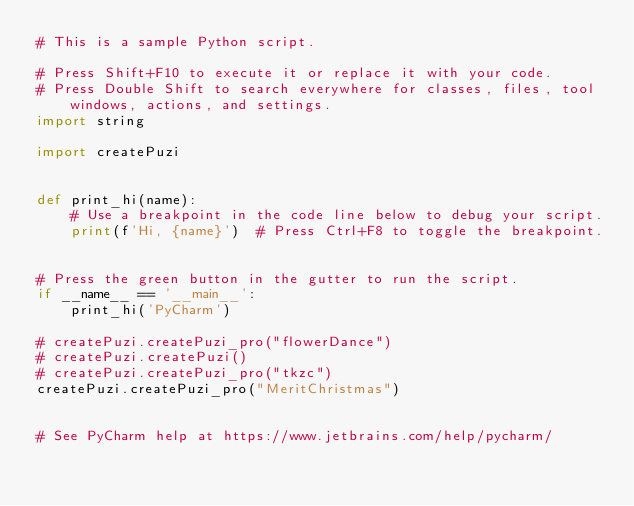Convert code to text. <code><loc_0><loc_0><loc_500><loc_500><_Python_># This is a sample Python script.

# Press Shift+F10 to execute it or replace it with your code.
# Press Double Shift to search everywhere for classes, files, tool windows, actions, and settings.
import string

import createPuzi


def print_hi(name):
    # Use a breakpoint in the code line below to debug your script.
    print(f'Hi, {name}')  # Press Ctrl+F8 to toggle the breakpoint.


# Press the green button in the gutter to run the script.
if __name__ == '__main__':
    print_hi('PyCharm')

# createPuzi.createPuzi_pro("flowerDance")
# createPuzi.createPuzi()
# createPuzi.createPuzi_pro("tkzc")
createPuzi.createPuzi_pro("MeritChristmas")


# See PyCharm help at https://www.jetbrains.com/help/pycharm/

</code> 